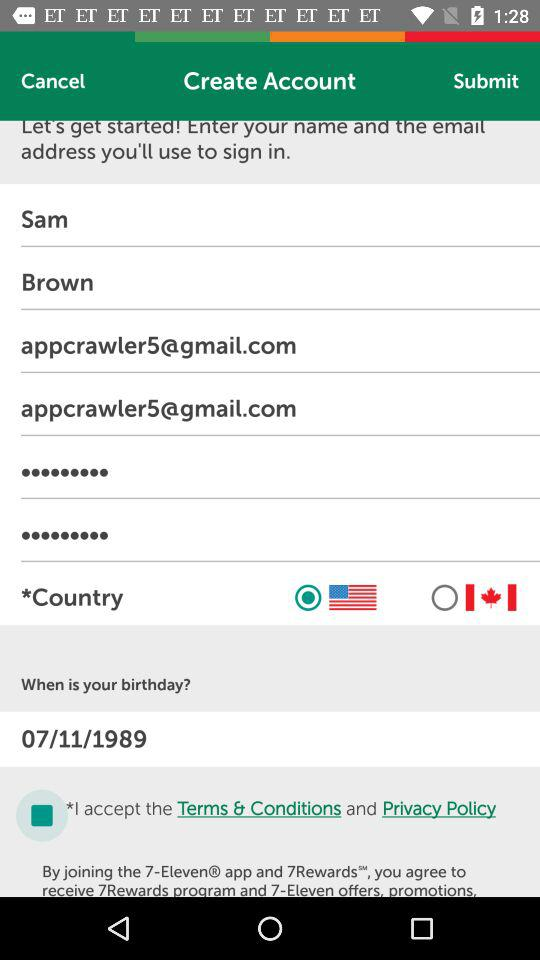What is the date of birth? The date of birth is July 11, 1989. 